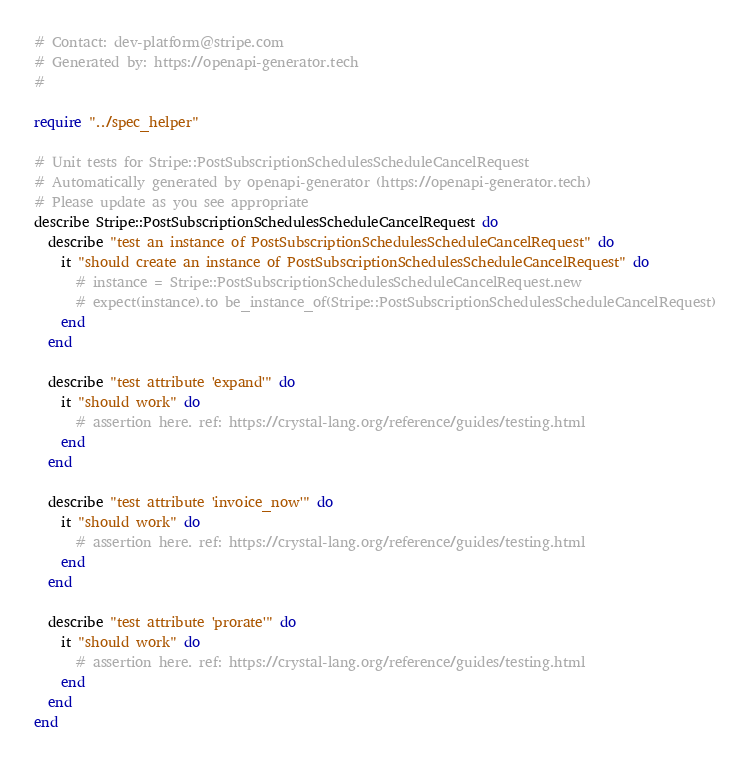<code> <loc_0><loc_0><loc_500><loc_500><_Crystal_># Contact: dev-platform@stripe.com
# Generated by: https://openapi-generator.tech
#

require "../spec_helper"

# Unit tests for Stripe::PostSubscriptionSchedulesScheduleCancelRequest
# Automatically generated by openapi-generator (https://openapi-generator.tech)
# Please update as you see appropriate
describe Stripe::PostSubscriptionSchedulesScheduleCancelRequest do
  describe "test an instance of PostSubscriptionSchedulesScheduleCancelRequest" do
    it "should create an instance of PostSubscriptionSchedulesScheduleCancelRequest" do
      # instance = Stripe::PostSubscriptionSchedulesScheduleCancelRequest.new
      # expect(instance).to be_instance_of(Stripe::PostSubscriptionSchedulesScheduleCancelRequest)
    end
  end

  describe "test attribute 'expand'" do
    it "should work" do
      # assertion here. ref: https://crystal-lang.org/reference/guides/testing.html
    end
  end

  describe "test attribute 'invoice_now'" do
    it "should work" do
      # assertion here. ref: https://crystal-lang.org/reference/guides/testing.html
    end
  end

  describe "test attribute 'prorate'" do
    it "should work" do
      # assertion here. ref: https://crystal-lang.org/reference/guides/testing.html
    end
  end
end
</code> 